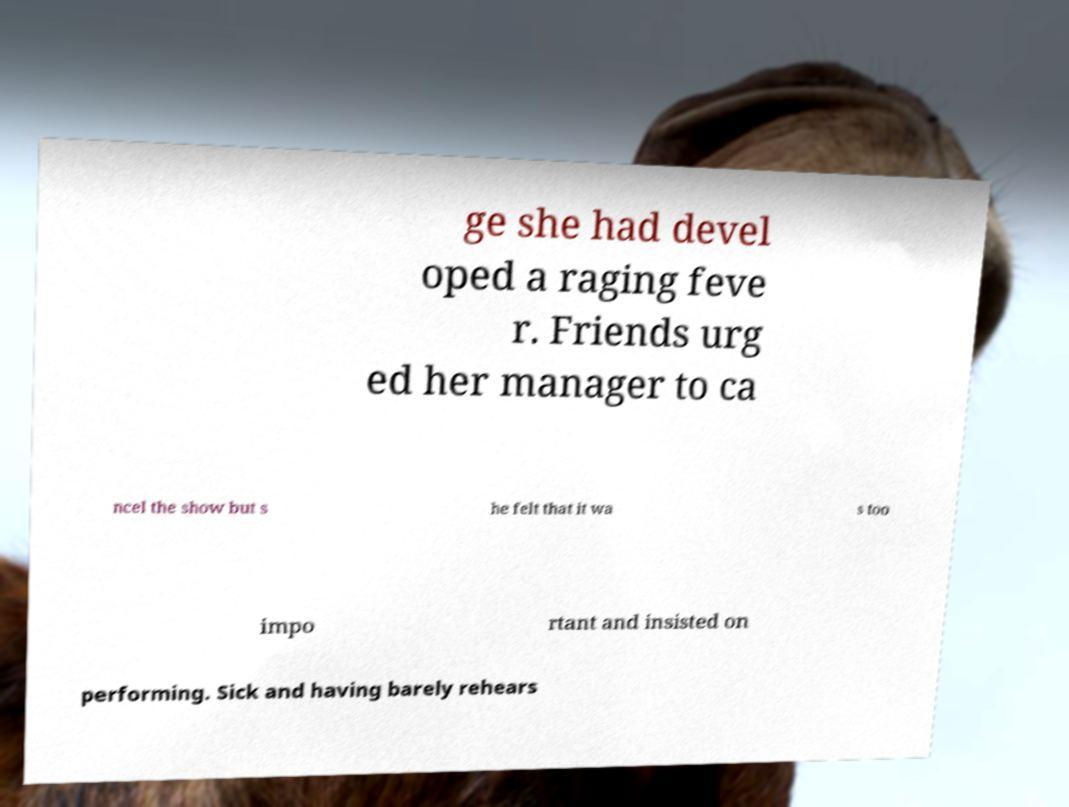Can you accurately transcribe the text from the provided image for me? ge she had devel oped a raging feve r. Friends urg ed her manager to ca ncel the show but s he felt that it wa s too impo rtant and insisted on performing. Sick and having barely rehears 